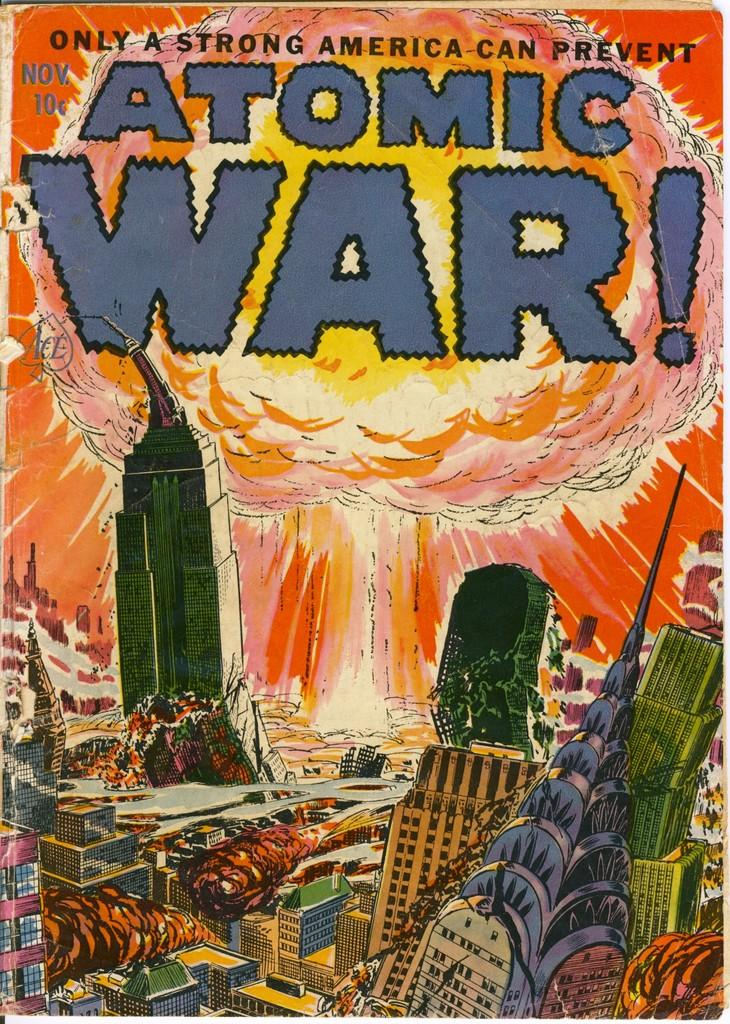What type of visual representation is shown in the image? The image is a poster. What kind of structures are depicted in the poster? There are buildings depicted in the poster. What is the nature of the depicted fire in the poster? There is fire depicted in the poster. What else can be seen in the poster besides buildings and fire? There are objects depicted in the poster. Is there any text present in the poster? Yes, there is text present in the poster. What type of scarf is being used to prevent the spread of the depicted disease in the image? There is no scarf or disease depicted in the image; it features a poster with buildings, fire, objects, and text. 